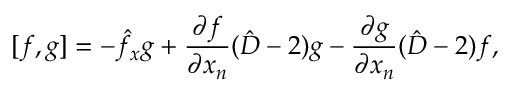Convert formula to latex. <formula><loc_0><loc_0><loc_500><loc_500>{ } [ f , g ] = - \hat { f } _ { x } g + \frac { \partial f } { \partial x _ { n } } ( \hat { D } - 2 ) g - \frac { \partial g } { \partial x _ { n } } ( \hat { D } - 2 ) f ,</formula> 